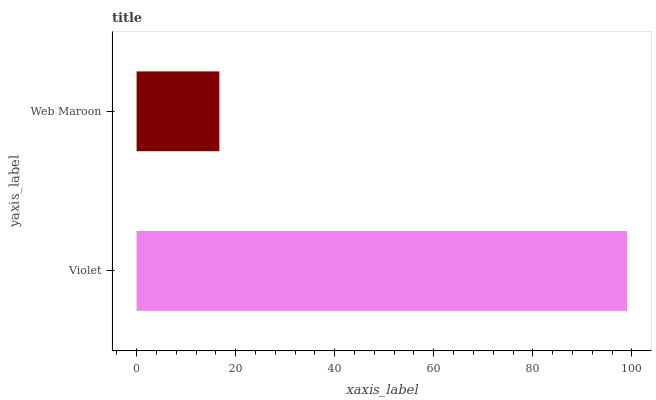Is Web Maroon the minimum?
Answer yes or no. Yes. Is Violet the maximum?
Answer yes or no. Yes. Is Web Maroon the maximum?
Answer yes or no. No. Is Violet greater than Web Maroon?
Answer yes or no. Yes. Is Web Maroon less than Violet?
Answer yes or no. Yes. Is Web Maroon greater than Violet?
Answer yes or no. No. Is Violet less than Web Maroon?
Answer yes or no. No. Is Violet the high median?
Answer yes or no. Yes. Is Web Maroon the low median?
Answer yes or no. Yes. Is Web Maroon the high median?
Answer yes or no. No. Is Violet the low median?
Answer yes or no. No. 